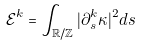Convert formula to latex. <formula><loc_0><loc_0><loc_500><loc_500>\mathcal { E } ^ { k } = \int _ { \mathbb { R } / \mathbb { Z } } | \partial _ { s } ^ { k } \kappa | ^ { 2 } d s</formula> 